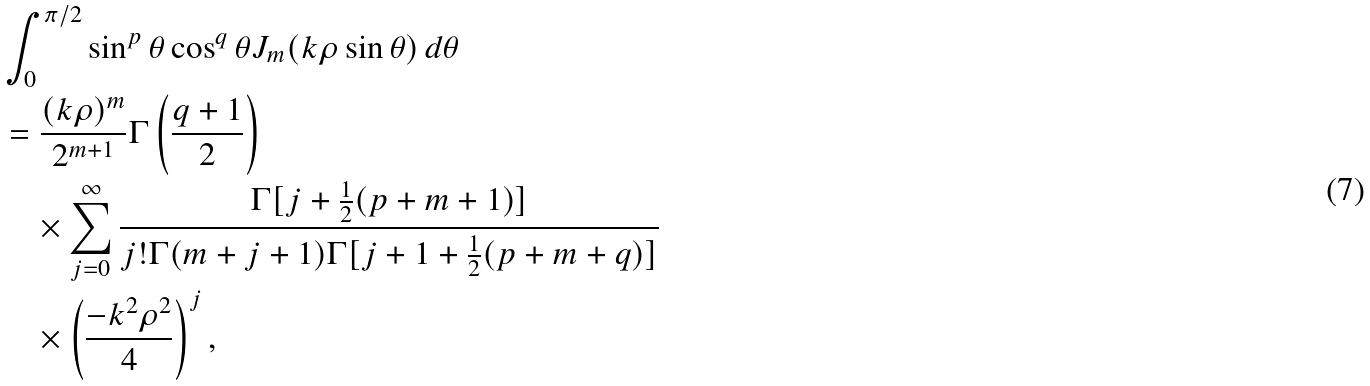<formula> <loc_0><loc_0><loc_500><loc_500>& \int _ { 0 } ^ { \pi / 2 } \sin ^ { p } \theta \cos ^ { q } \theta J _ { m } ( k \rho \sin \theta ) \, d \theta \\ & = \frac { ( k \rho ) ^ { m } } { 2 ^ { m + 1 } } \Gamma \left ( \frac { q + 1 } { 2 } \right ) \\ & \quad \times \sum _ { j = 0 } ^ { \infty } \frac { \Gamma [ j + \frac { 1 } { 2 } ( p + m + 1 ) ] } { j ! \Gamma ( m + j + 1 ) \Gamma [ j + 1 + \frac { 1 } { 2 } ( p + m + q ) ] } \\ & \quad \times \left ( \frac { - k ^ { 2 } \rho ^ { 2 } } { 4 } \right ) ^ { j } ,</formula> 